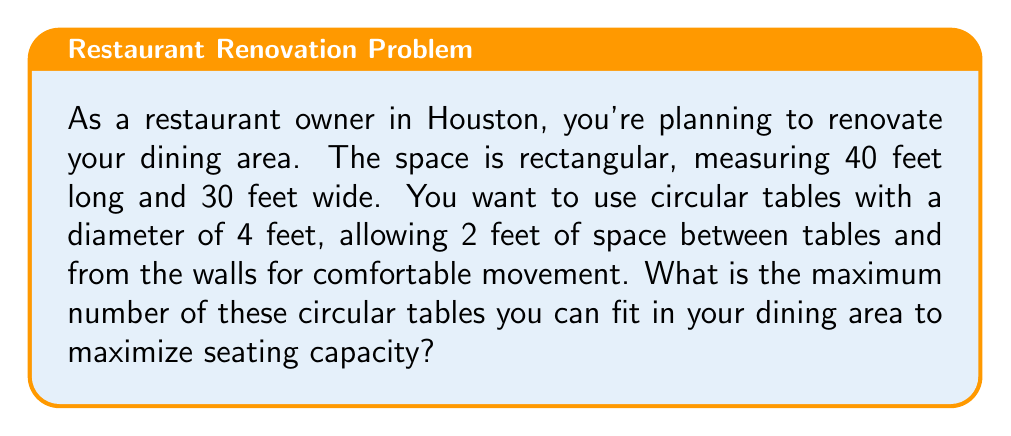Teach me how to tackle this problem. Let's approach this step-by-step:

1) First, we need to calculate the effective area where tables can be placed. We'll subtract 2 feet from each side to account for the required spacing:
   
   Effective length = $40 - (2 * 2) = 36$ feet
   Effective width = $30 - (2 * 2) = 26$ feet

2) Now, we need to determine how many tables can fit along each dimension. Each table, including its spacing, occupies a 6-foot square (4 feet for the table + 2 feet for spacing):

   Tables along length = $\lfloor \frac{36}{6} \rfloor = 6$ (using floor function)
   Tables along width = $\lfloor \frac{26}{6} \rfloor = 4$

3) The total number of tables is the product of these two values:

   Total tables = $6 * 4 = 24$

4) To verify, let's visualize the arrangement:

[asy]
size(200);
for(int i=0; i<6; ++i)
  for(int j=0; j<4; ++j)
    draw(circle((i*6+3,j*6+3),2));
draw(box((0,0),(36,26)));
[/asy]

This diagram confirms that 24 tables fit within the space while maintaining the required spacing.
Answer: The maximum number of circular tables that can fit in the dining area is 24. 